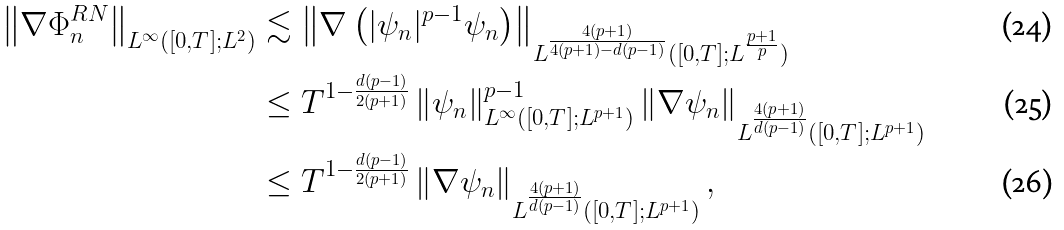Convert formula to latex. <formula><loc_0><loc_0><loc_500><loc_500>\left \| \nabla \Phi ^ { R N } _ { n } \right \| _ { L ^ { \infty } ( [ 0 , T ] ; L ^ { 2 } ) } & \lesssim \left \| \nabla \left ( | \psi _ { n } | ^ { p - 1 } \psi _ { n } \right ) \right \| _ { L ^ { \frac { 4 ( p + 1 ) } { 4 ( p + 1 ) - d ( p - 1 ) } } ( [ 0 , T ] ; L ^ { \frac { p + 1 } { p } } ) } \\ & \leq T ^ { 1 - \frac { d ( p - 1 ) } { 2 ( p + 1 ) } } \left \| \psi _ { n } \right \| _ { L ^ { \infty } ( [ 0 , T ] ; L ^ { p + 1 } ) } ^ { p - 1 } \left \| \nabla \psi _ { n } \right \| _ { L ^ { \frac { 4 ( p + 1 ) } { d ( p - 1 ) } } ( [ 0 , T ] ; L ^ { p + 1 } ) } \\ & \leq T ^ { 1 - \frac { d ( p - 1 ) } { 2 ( p + 1 ) } } \left \| \nabla \psi _ { n } \right \| _ { L ^ { \frac { 4 ( p + 1 ) } { d ( p - 1 ) } } ( [ 0 , T ] ; L ^ { p + 1 } ) } ,</formula> 